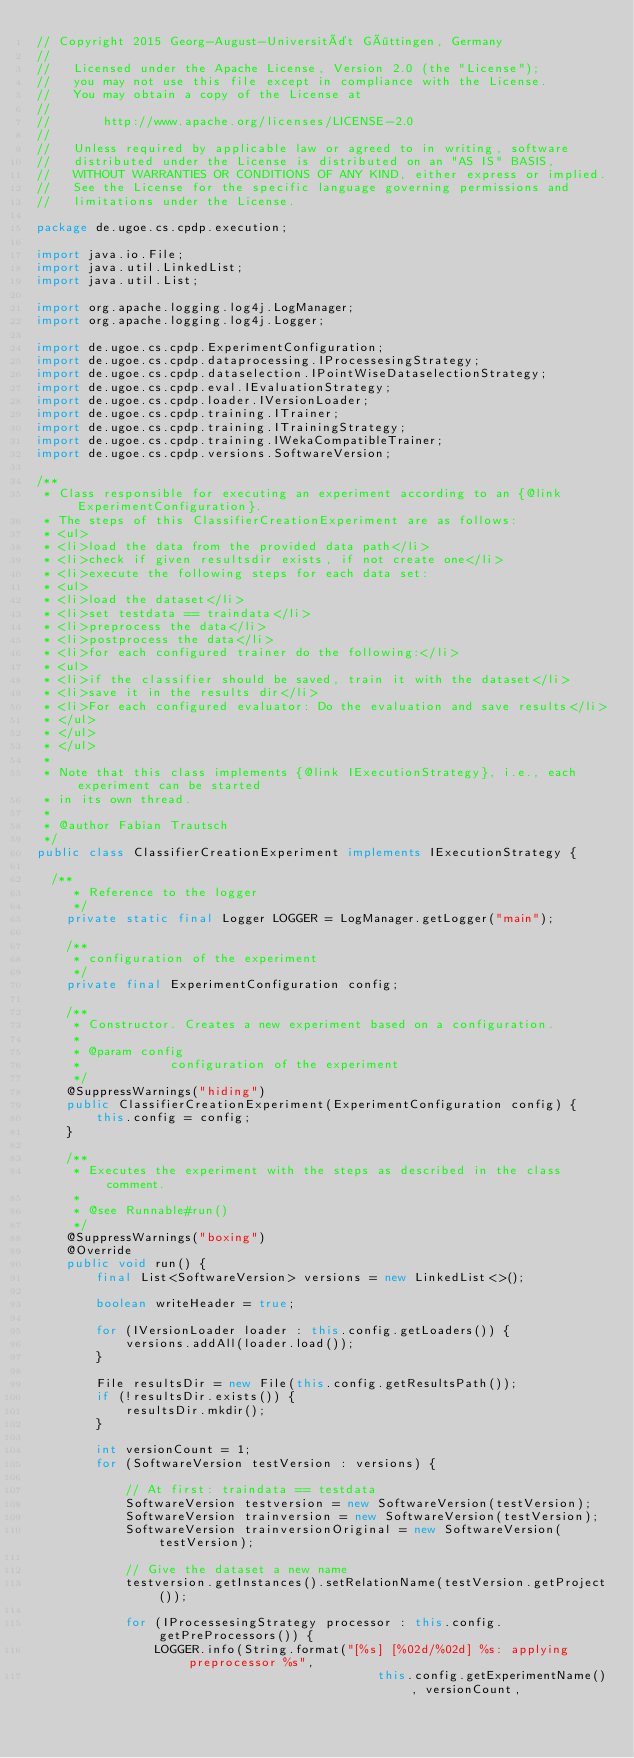Convert code to text. <code><loc_0><loc_0><loc_500><loc_500><_Java_>// Copyright 2015 Georg-August-Universität Göttingen, Germany
//
//   Licensed under the Apache License, Version 2.0 (the "License");
//   you may not use this file except in compliance with the License.
//   You may obtain a copy of the License at
//
//       http://www.apache.org/licenses/LICENSE-2.0
//
//   Unless required by applicable law or agreed to in writing, software
//   distributed under the License is distributed on an "AS IS" BASIS,
//   WITHOUT WARRANTIES OR CONDITIONS OF ANY KIND, either express or implied.
//   See the License for the specific language governing permissions and
//   limitations under the License.

package de.ugoe.cs.cpdp.execution;

import java.io.File;
import java.util.LinkedList;
import java.util.List;

import org.apache.logging.log4j.LogManager;
import org.apache.logging.log4j.Logger;

import de.ugoe.cs.cpdp.ExperimentConfiguration;
import de.ugoe.cs.cpdp.dataprocessing.IProcessesingStrategy;
import de.ugoe.cs.cpdp.dataselection.IPointWiseDataselectionStrategy;
import de.ugoe.cs.cpdp.eval.IEvaluationStrategy;
import de.ugoe.cs.cpdp.loader.IVersionLoader;
import de.ugoe.cs.cpdp.training.ITrainer;
import de.ugoe.cs.cpdp.training.ITrainingStrategy;
import de.ugoe.cs.cpdp.training.IWekaCompatibleTrainer;
import de.ugoe.cs.cpdp.versions.SoftwareVersion;

/**
 * Class responsible for executing an experiment according to an {@link ExperimentConfiguration}.
 * The steps of this ClassifierCreationExperiment are as follows:
 * <ul>
 * <li>load the data from the provided data path</li>
 * <li>check if given resultsdir exists, if not create one</li>
 * <li>execute the following steps for each data set:
 * <ul>
 * <li>load the dataset</li>
 * <li>set testdata == traindata</li>
 * <li>preprocess the data</li>
 * <li>postprocess the data</li>
 * <li>for each configured trainer do the following:</li>
 * <ul>
 * <li>if the classifier should be saved, train it with the dataset</li>
 * <li>save it in the results dir</li>
 * <li>For each configured evaluator: Do the evaluation and save results</li>
 * </ul>
 * </ul>
 * </ul>
 * 
 * Note that this class implements {@link IExecutionStrategy}, i.e., each experiment can be started
 * in its own thread.
 * 
 * @author Fabian Trautsch
 */
public class ClassifierCreationExperiment implements IExecutionStrategy {

	/**
     * Reference to the logger
     */
    private static final Logger LOGGER = LogManager.getLogger("main");
	
    /**
     * configuration of the experiment
     */
    private final ExperimentConfiguration config;

    /**
     * Constructor. Creates a new experiment based on a configuration.
     * 
     * @param config
     *            configuration of the experiment
     */
    @SuppressWarnings("hiding")
    public ClassifierCreationExperiment(ExperimentConfiguration config) {
        this.config = config;
    }

    /**
     * Executes the experiment with the steps as described in the class comment.
     * 
     * @see Runnable#run()
     */
    @SuppressWarnings("boxing")
    @Override
    public void run() {
        final List<SoftwareVersion> versions = new LinkedList<>();

        boolean writeHeader = true;

        for (IVersionLoader loader : this.config.getLoaders()) {
            versions.addAll(loader.load());
        }

        File resultsDir = new File(this.config.getResultsPath());
        if (!resultsDir.exists()) {
            resultsDir.mkdir();
        }

        int versionCount = 1;
        for (SoftwareVersion testVersion : versions) {

            // At first: traindata == testdata
            SoftwareVersion testversion = new SoftwareVersion(testVersion);
            SoftwareVersion trainversion = new SoftwareVersion(testVersion);
            SoftwareVersion trainversionOriginal = new SoftwareVersion(testVersion);

            // Give the dataset a new name
            testversion.getInstances().setRelationName(testVersion.getProject());

            for (IProcessesingStrategy processor : this.config.getPreProcessors()) {
                LOGGER.info(String.format("[%s] [%02d/%02d] %s: applying preprocessor %s",
                                              this.config.getExperimentName(), versionCount,</code> 